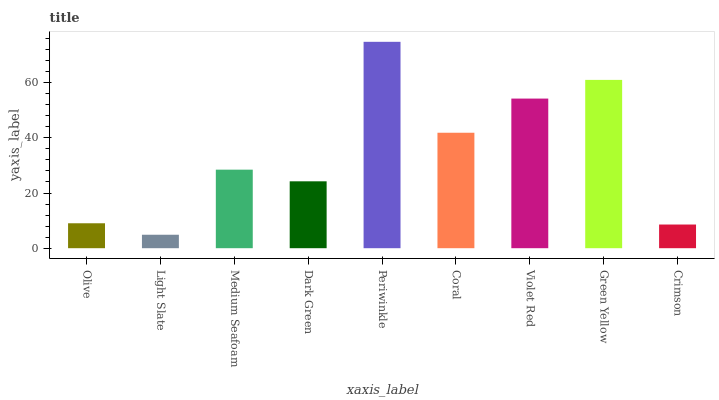Is Medium Seafoam the minimum?
Answer yes or no. No. Is Medium Seafoam the maximum?
Answer yes or no. No. Is Medium Seafoam greater than Light Slate?
Answer yes or no. Yes. Is Light Slate less than Medium Seafoam?
Answer yes or no. Yes. Is Light Slate greater than Medium Seafoam?
Answer yes or no. No. Is Medium Seafoam less than Light Slate?
Answer yes or no. No. Is Medium Seafoam the high median?
Answer yes or no. Yes. Is Medium Seafoam the low median?
Answer yes or no. Yes. Is Olive the high median?
Answer yes or no. No. Is Coral the low median?
Answer yes or no. No. 